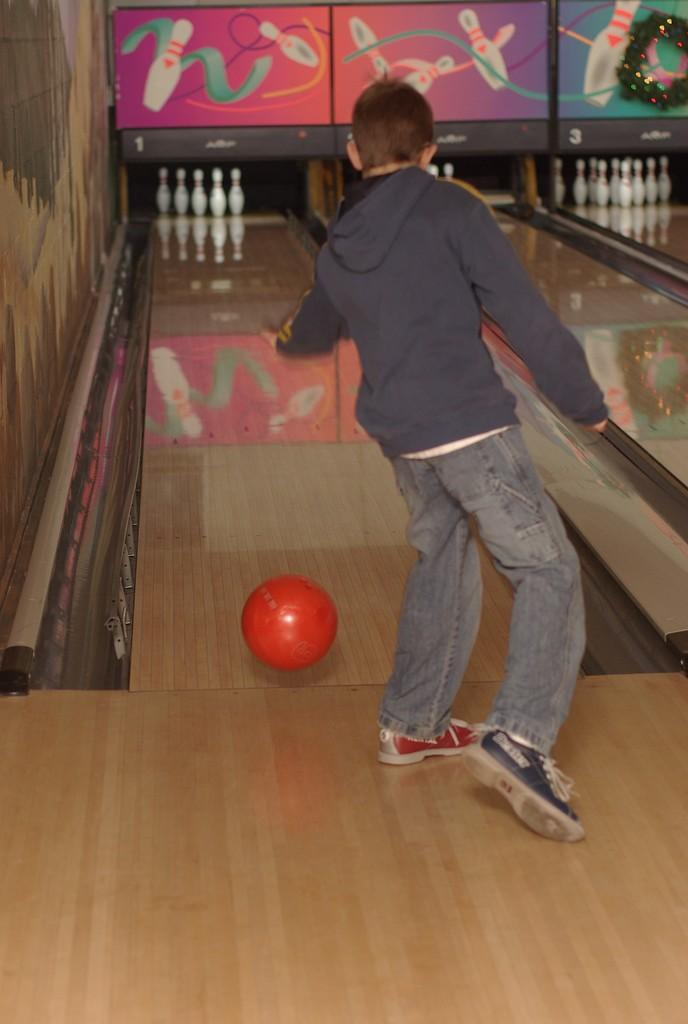Who or what is in the image? There is a person in the image. What is the person doing or standing near? The person is standing in front of a ball. What else can be seen in the image related to the activity? Bowling pins are present in the image. Are there any other objects or surfaces visible? Yes, there are boards in the image. What type of produce is being traded in the image? There is no produce or trade activity present in the image. What kind of error can be seen in the image? There is no error visible in the image. 